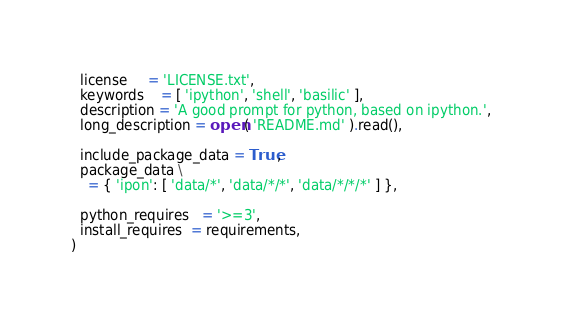<code> <loc_0><loc_0><loc_500><loc_500><_Python_>  license     = 'LICENSE.txt', 
  keywords    = [ 'ipython', 'shell', 'basilic' ], 
  description = 'A good prompt for python, based on ipython.', 
  long_description = open( 'README.md' ).read(), 
  
  include_package_data = True,
  package_data \
    = { 'ipon': [ 'data/*', 'data/*/*', 'data/*/*/*' ] },
  
  python_requires   = '>=3',
  install_requires  = requirements, 
)
</code> 